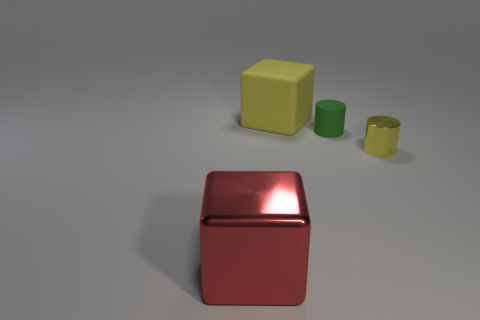Add 4 red matte cylinders. How many objects exist? 8 Add 3 green rubber blocks. How many green rubber blocks exist? 3 Subtract 0 gray cubes. How many objects are left? 4 Subtract all large red metallic things. Subtract all large purple shiny things. How many objects are left? 3 Add 3 big objects. How many big objects are left? 5 